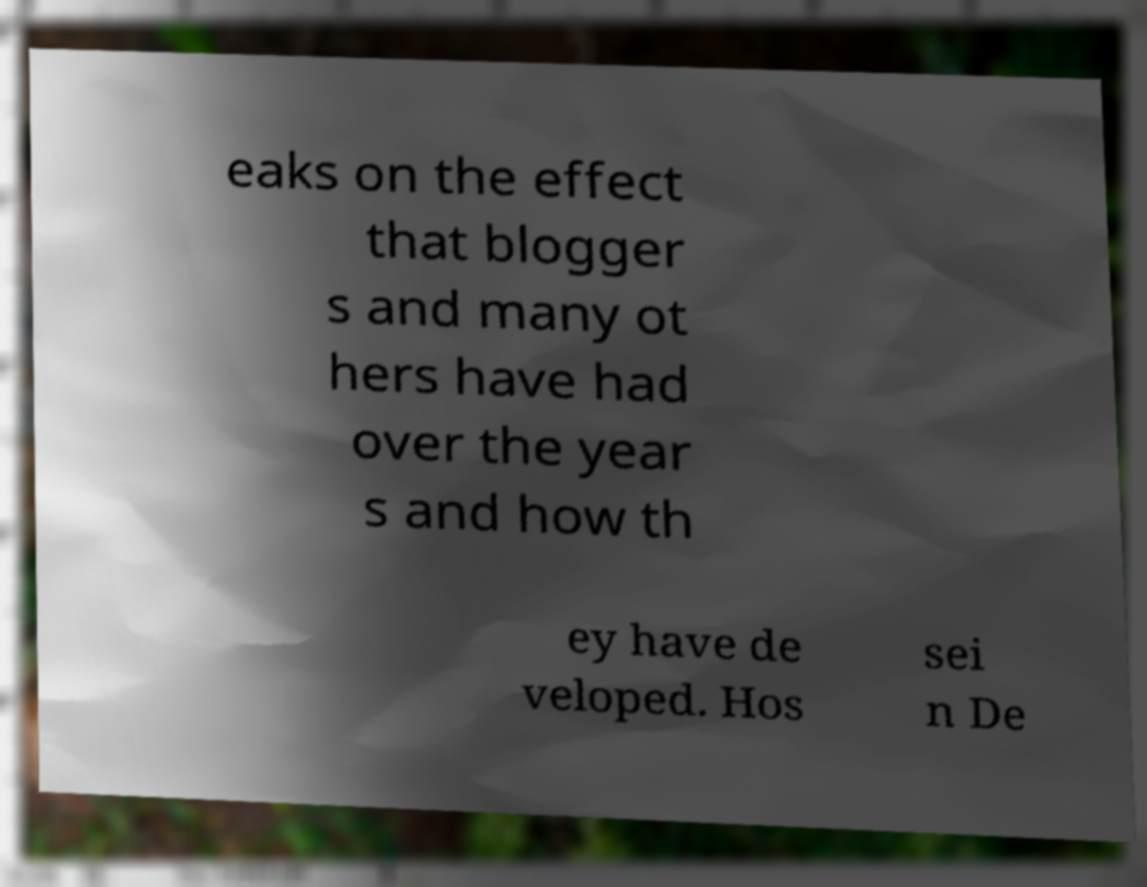Can you accurately transcribe the text from the provided image for me? eaks on the effect that blogger s and many ot hers have had over the year s and how th ey have de veloped. Hos sei n De 